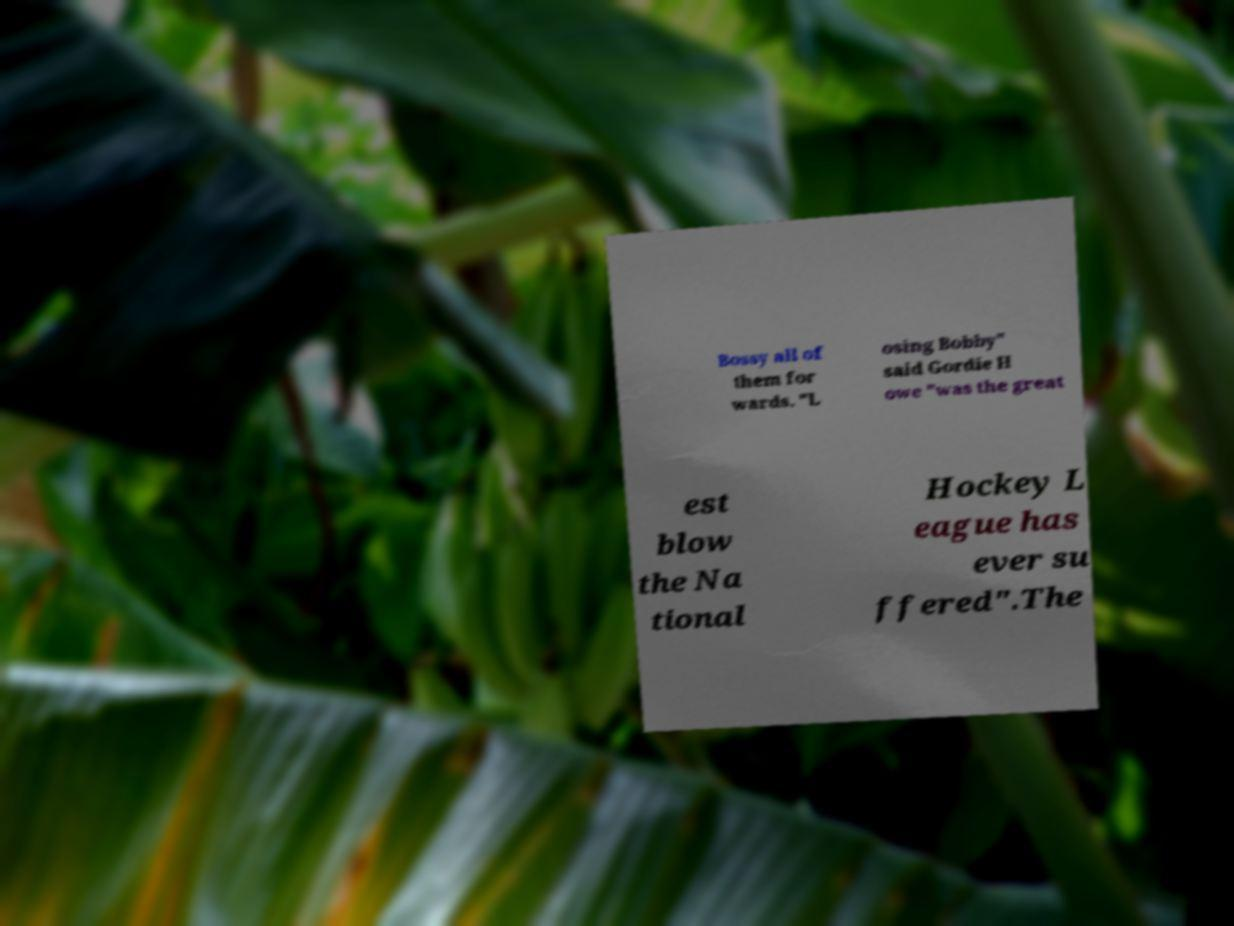Can you read and provide the text displayed in the image?This photo seems to have some interesting text. Can you extract and type it out for me? Bossy all of them for wards. "L osing Bobby" said Gordie H owe "was the great est blow the Na tional Hockey L eague has ever su ffered".The 